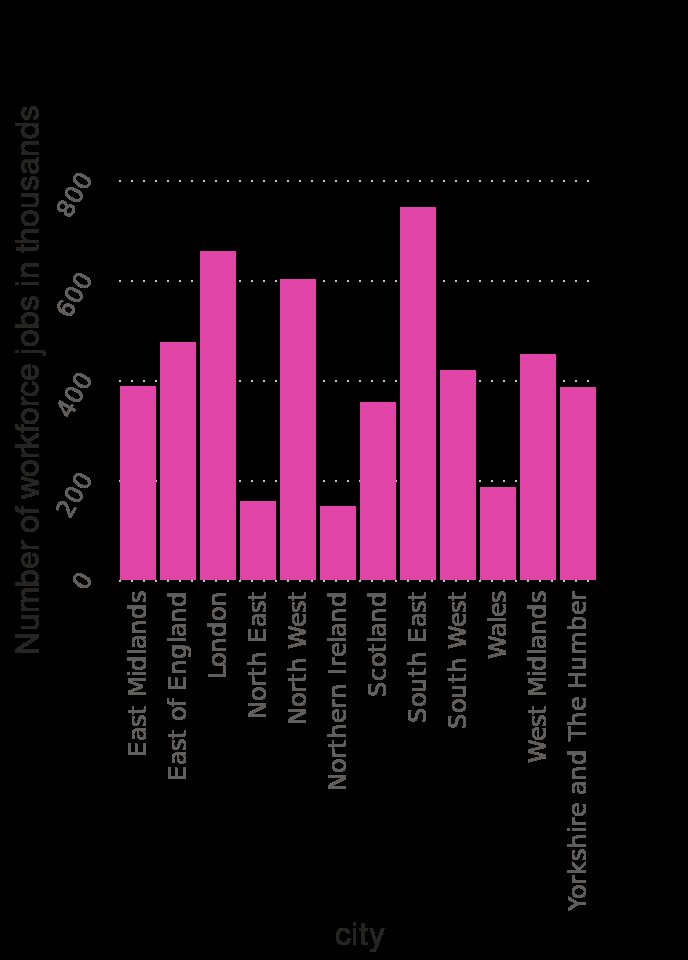<image>
What was the highest number in a region?  The highest number was in the South East. Which region had the highest number?  The South East had the highest number. Describe the following image in detail This bar plot is titled Workforce jobs in the wholesale and retail trade sector in the United Kingdom (UK) as of March 2020 , by region (in 1,000). The y-axis shows Number of workforce jobs in thousands using linear scale with a minimum of 0 and a maximum of 800 while the x-axis shows city on categorical scale starting at East Midlands and ending at . 